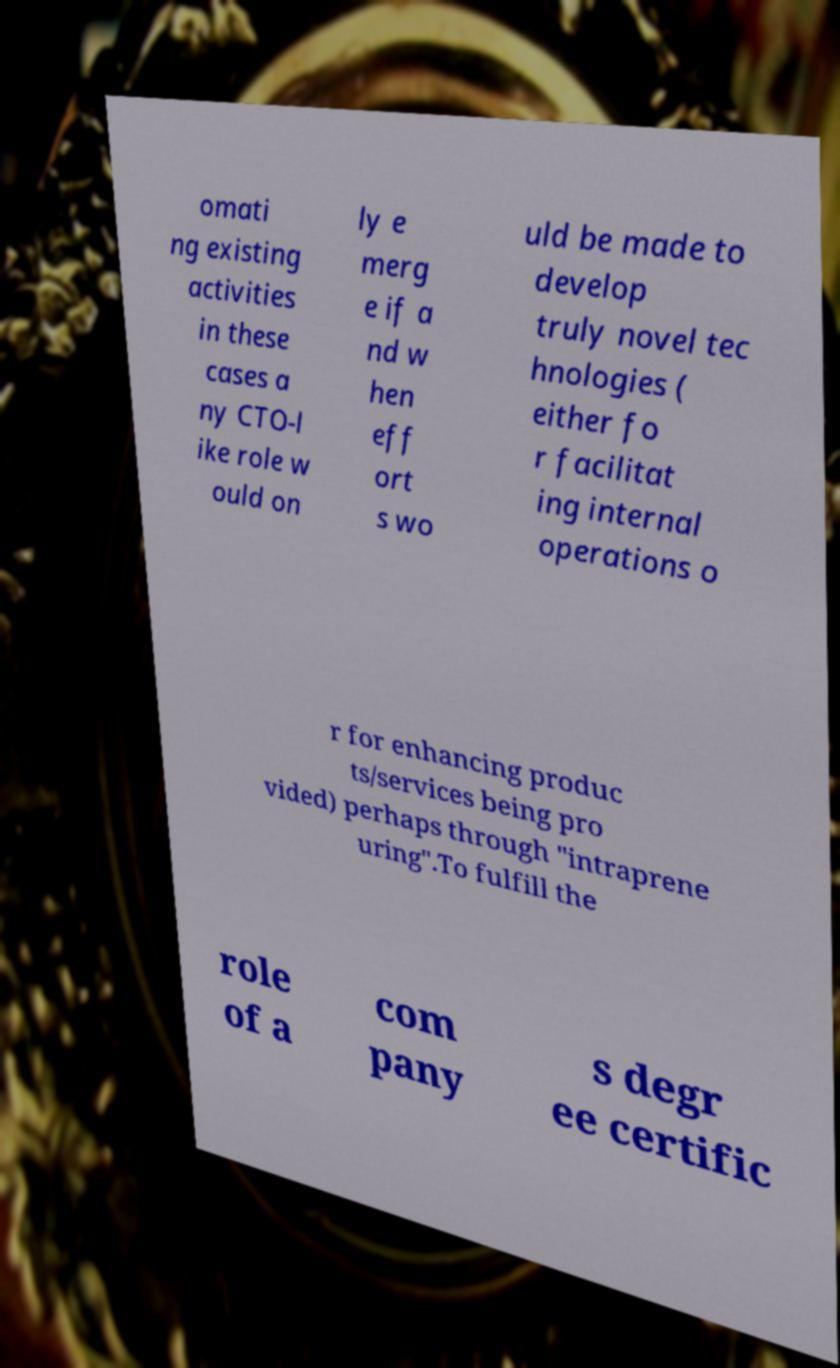For documentation purposes, I need the text within this image transcribed. Could you provide that? omati ng existing activities in these cases a ny CTO-l ike role w ould on ly e merg e if a nd w hen eff ort s wo uld be made to develop truly novel tec hnologies ( either fo r facilitat ing internal operations o r for enhancing produc ts/services being pro vided) perhaps through "intraprene uring".To fulfill the role of a com pany s degr ee certific 